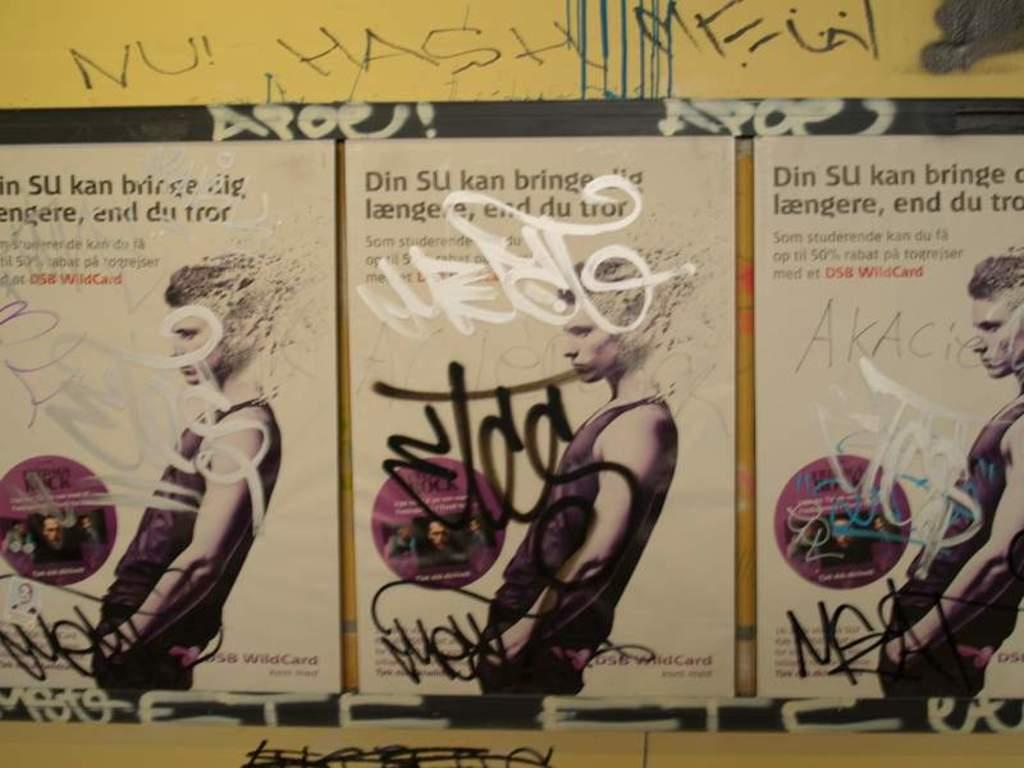What type of visual elements can be seen on the wall in the image? There are posters in the image. What else can be found on the wall besides the posters? There is text on the wall in the image. How does the ray of sunshine interact with the friend in the image? There is no friend or ray of sunshine present in the image. 